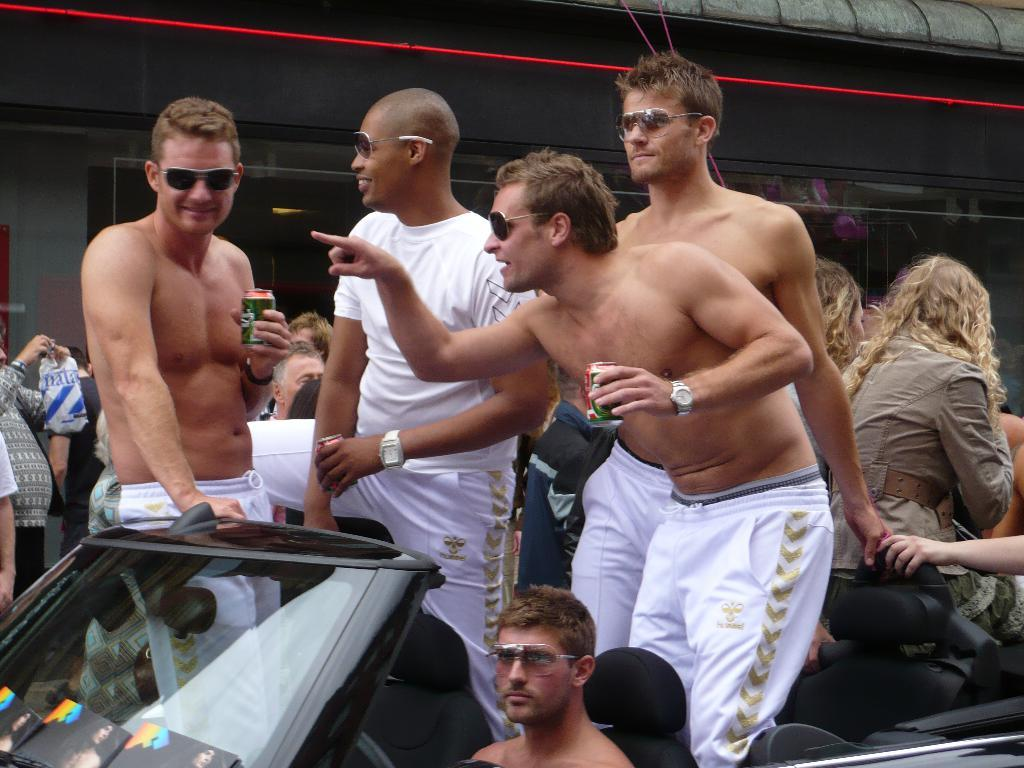What is the main subject of the image? The main subject of the image is a vehicle. Are there any people in the image? Yes, there are people inside the vehicle. Can you describe the appearance of one of the people inside the vehicle? One person in the vehicle is wearing a white shirt. What else can be seen in the image besides the vehicle and the people inside it? There are other people around the vehicle. What type of silver material is being rubbed by the person in the white shirt? There is no silver material or rubbing action mentioned or depicted in the image. 